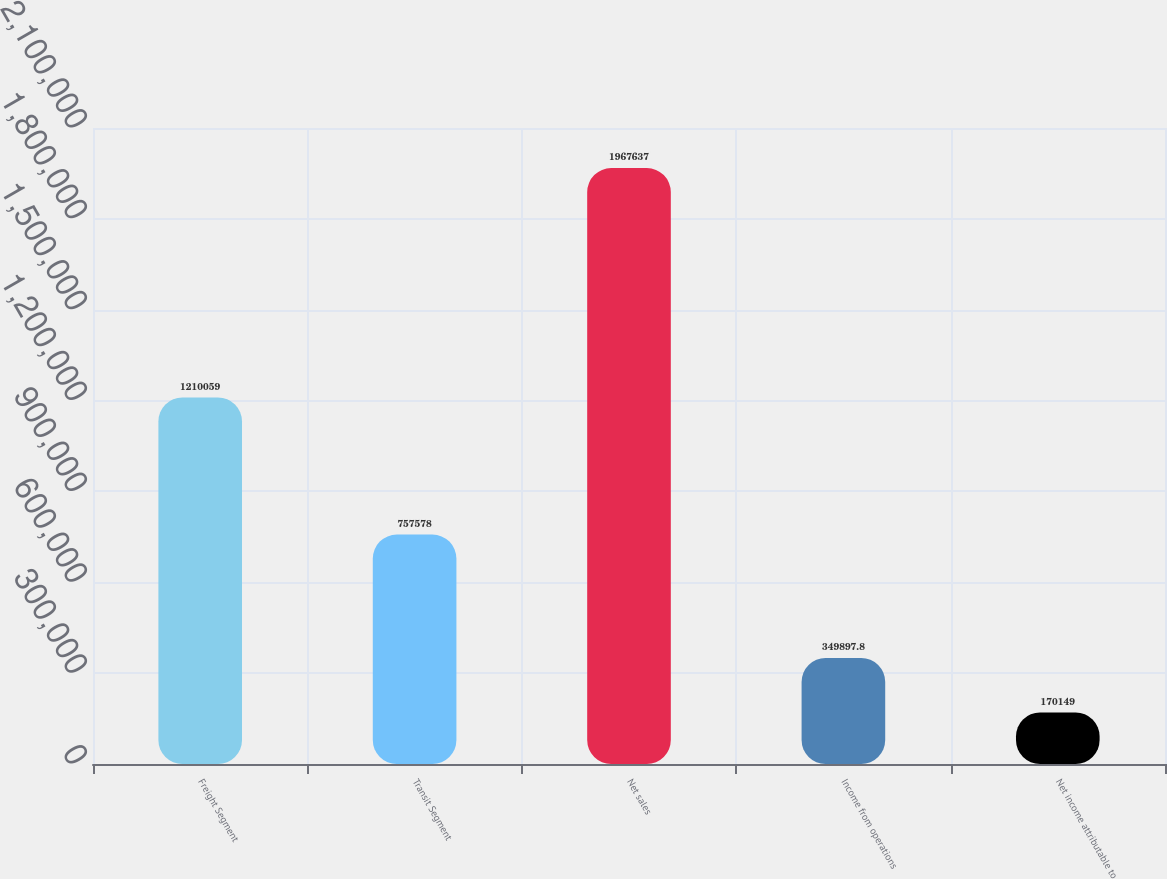Convert chart. <chart><loc_0><loc_0><loc_500><loc_500><bar_chart><fcel>Freight Segment<fcel>Transit Segment<fcel>Net sales<fcel>Income from operations<fcel>Net income attributable to<nl><fcel>1.21006e+06<fcel>757578<fcel>1.96764e+06<fcel>349898<fcel>170149<nl></chart> 